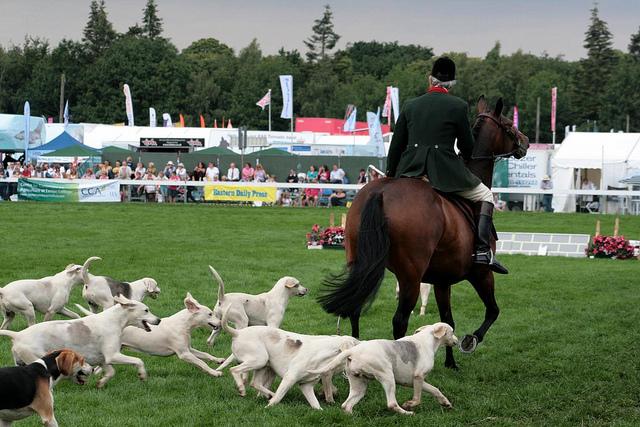Where are the dogs?
Concise answer only. Behind horse. What color is the horse's mane?
Concise answer only. Black. How many dogs are there?
Concise answer only. 9. Are the dogs all the same color?
Quick response, please. No. 